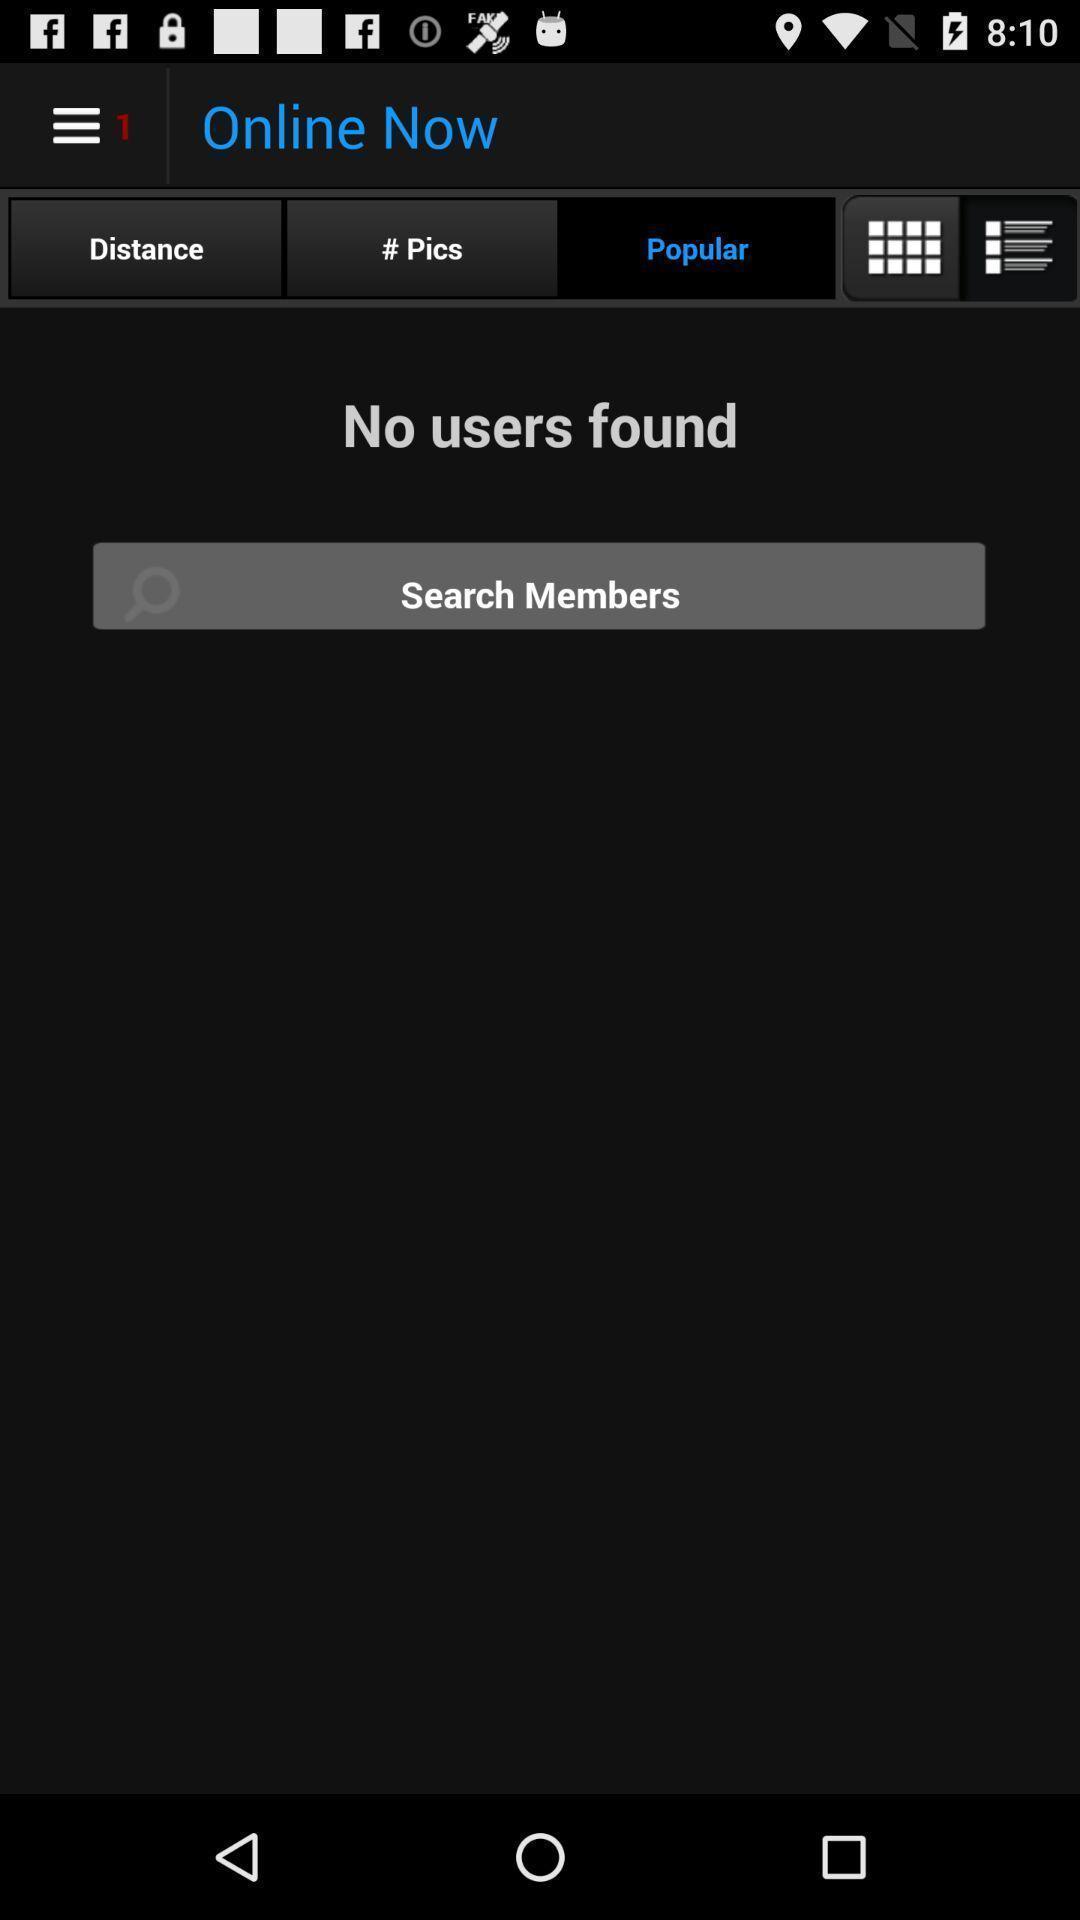Describe the key features of this screenshot. Page showing results and multiple icons. 